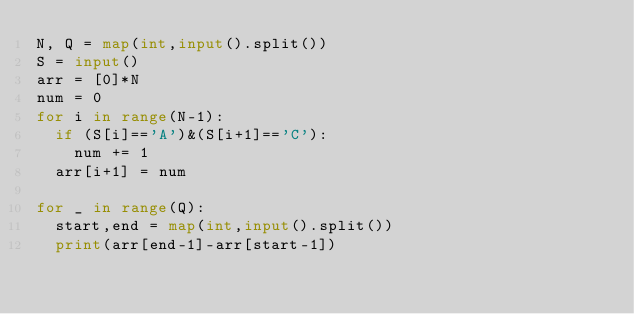<code> <loc_0><loc_0><loc_500><loc_500><_Python_>N, Q = map(int,input().split())
S = input()
arr = [0]*N
num = 0
for i in range(N-1):
  if (S[i]=='A')&(S[i+1]=='C'):
    num += 1
  arr[i+1] = num

for _ in range(Q):
  start,end = map(int,input().split())
  print(arr[end-1]-arr[start-1])
  </code> 